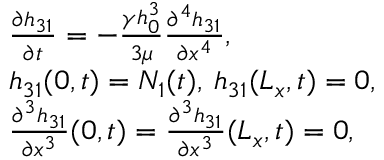Convert formula to latex. <formula><loc_0><loc_0><loc_500><loc_500>\begin{array} { r l } & { \frac { \partial h _ { 3 1 } } { \partial t } = - \frac { \gamma h _ { 0 } ^ { 3 } } { 3 \mu } \frac { \partial ^ { 4 } h _ { 3 1 } } { \partial x ^ { 4 } } , } \\ & { h _ { 3 1 } ( 0 , t ) = N _ { 1 } ( t ) , \, h _ { 3 1 } ( L _ { x } , t ) = 0 , } \\ & { \frac { \partial ^ { 3 } h _ { 3 1 } } { \partial x ^ { 3 } } ( 0 , t ) = \frac { \partial ^ { 3 } h _ { 3 1 } } { \partial x ^ { 3 } } ( L _ { x } , t ) = 0 , } \end{array}</formula> 